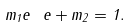Convert formula to latex. <formula><loc_0><loc_0><loc_500><loc_500>m _ { 1 } e ^ { \ } e + m _ { 2 } = 1 .</formula> 